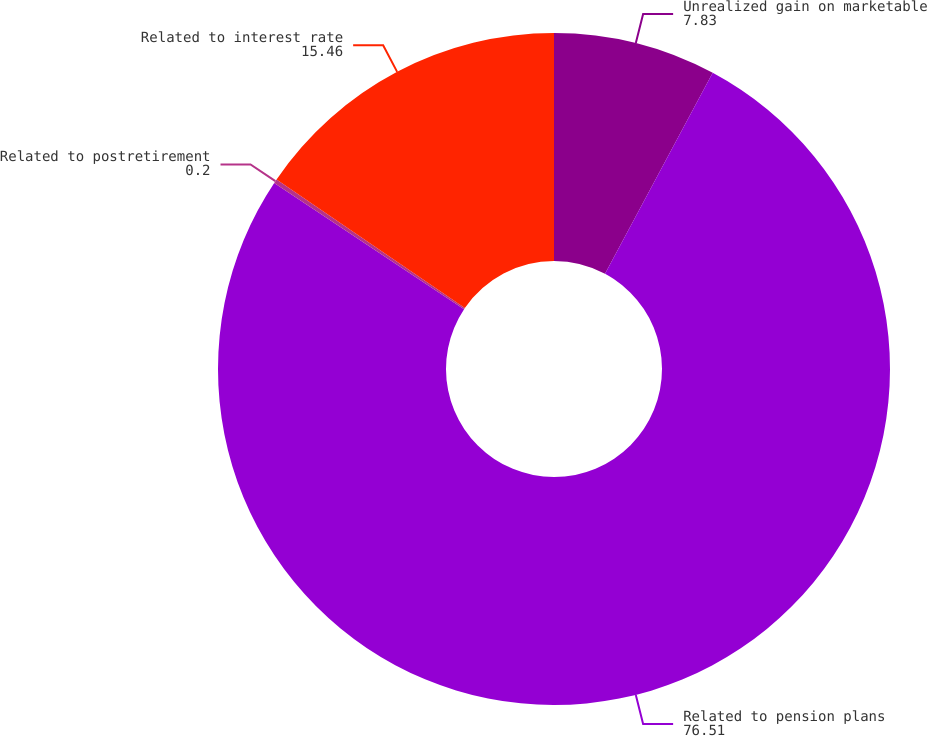Convert chart. <chart><loc_0><loc_0><loc_500><loc_500><pie_chart><fcel>Unrealized gain on marketable<fcel>Related to pension plans<fcel>Related to postretirement<fcel>Related to interest rate<nl><fcel>7.83%<fcel>76.51%<fcel>0.2%<fcel>15.46%<nl></chart> 